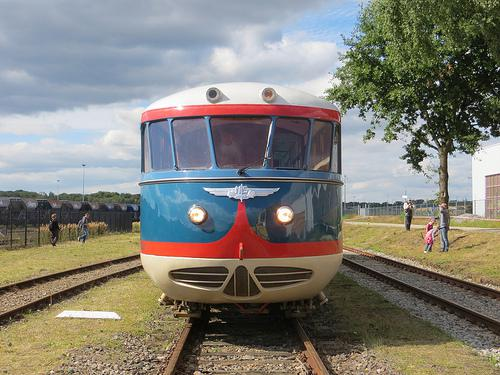Question: where is a train?
Choices:
A. In the shop.
B. Over the hill.
C. On the bridge.
D. On train tracks.
Answer with the letter. Answer: D Question: where are clouds?
Choices:
A. Behind the mountain.
B. There are no clouds.
C. On the painting.
D. In the sky.
Answer with the letter. Answer: D Question: what is blue?
Choices:
A. The cup.
B. The car.
C. Sky.
D. The wall.
Answer with the letter. Answer: C Question: what is green?
Choices:
A. Tractor.
B. Grass.
C. The car.
D. The tree leaves.
Answer with the letter. Answer: B Question: where are windows?
Choices:
A. On a train.
B. In the house.
C. On the shelf.
D. Beside the shed.
Answer with the letter. Answer: A 